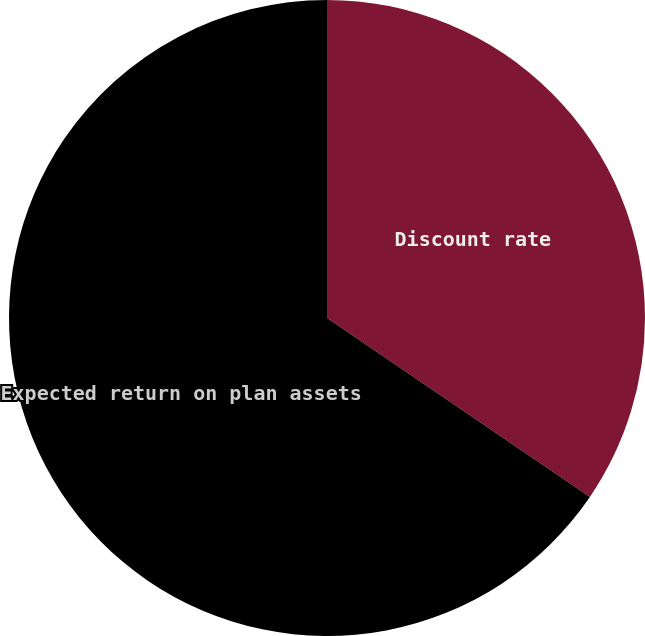Convert chart to OTSL. <chart><loc_0><loc_0><loc_500><loc_500><pie_chart><fcel>Discount rate<fcel>Expected return on plan assets<nl><fcel>34.51%<fcel>65.49%<nl></chart> 